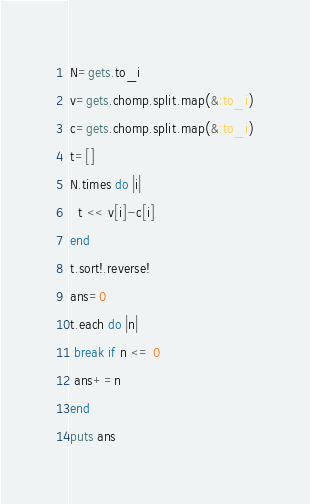<code> <loc_0><loc_0><loc_500><loc_500><_Ruby_>N=gets.to_i
v=gets.chomp.split.map(&:to_i)
c=gets.chomp.split.map(&:to_i)
t=[]
N.times do |i|
  t << v[i]-c[i]
end
t.sort!.reverse!
ans=0
t.each do |n|
 break if n <= 0
 ans+=n
end
puts ans</code> 